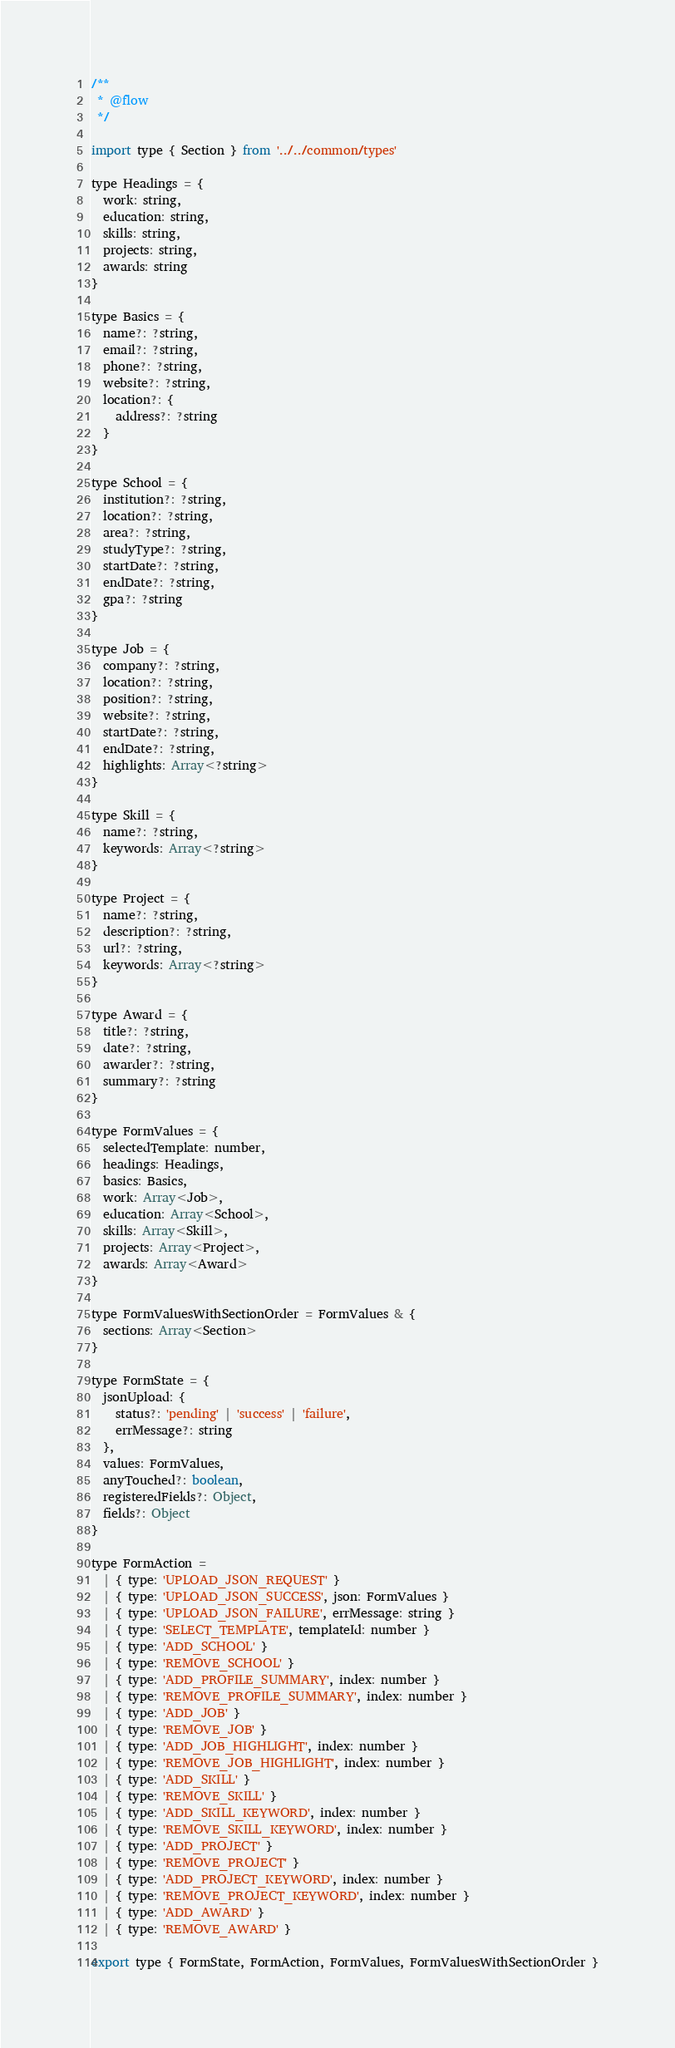<code> <loc_0><loc_0><loc_500><loc_500><_JavaScript_>/**
 * @flow
 */

import type { Section } from '../../common/types'

type Headings = {
  work: string,
  education: string,
  skills: string,
  projects: string,
  awards: string
}

type Basics = {
  name?: ?string,
  email?: ?string,
  phone?: ?string,
  website?: ?string,
  location?: {
    address?: ?string
  }
}

type School = {
  institution?: ?string,
  location?: ?string,
  area?: ?string,
  studyType?: ?string,
  startDate?: ?string,
  endDate?: ?string,
  gpa?: ?string
}

type Job = {
  company?: ?string,
  location?: ?string,
  position?: ?string,
  website?: ?string,
  startDate?: ?string,
  endDate?: ?string,
  highlights: Array<?string>
}

type Skill = {
  name?: ?string,
  keywords: Array<?string>
}

type Project = {
  name?: ?string,
  description?: ?string,
  url?: ?string,
  keywords: Array<?string>
}

type Award = {
  title?: ?string,
  date?: ?string,
  awarder?: ?string,
  summary?: ?string
}

type FormValues = {
  selectedTemplate: number,
  headings: Headings,
  basics: Basics,
  work: Array<Job>,
  education: Array<School>,
  skills: Array<Skill>,
  projects: Array<Project>,
  awards: Array<Award>
}

type FormValuesWithSectionOrder = FormValues & {
  sections: Array<Section>
}

type FormState = {
  jsonUpload: {
    status?: 'pending' | 'success' | 'failure',
    errMessage?: string
  },
  values: FormValues,
  anyTouched?: boolean,
  registeredFields?: Object,
  fields?: Object
}

type FormAction =
  | { type: 'UPLOAD_JSON_REQUEST' }
  | { type: 'UPLOAD_JSON_SUCCESS', json: FormValues }
  | { type: 'UPLOAD_JSON_FAILURE', errMessage: string }
  | { type: 'SELECT_TEMPLATE', templateId: number }
  | { type: 'ADD_SCHOOL' }
  | { type: 'REMOVE_SCHOOL' }
  | { type: 'ADD_PROFILE_SUMMARY', index: number }
  | { type: 'REMOVE_PROFILE_SUMMARY', index: number }
  | { type: 'ADD_JOB' }
  | { type: 'REMOVE_JOB' }
  | { type: 'ADD_JOB_HIGHLIGHT', index: number }
  | { type: 'REMOVE_JOB_HIGHLIGHT', index: number }
  | { type: 'ADD_SKILL' }
  | { type: 'REMOVE_SKILL' }
  | { type: 'ADD_SKILL_KEYWORD', index: number }
  | { type: 'REMOVE_SKILL_KEYWORD', index: number }
  | { type: 'ADD_PROJECT' }
  | { type: 'REMOVE_PROJECT' }
  | { type: 'ADD_PROJECT_KEYWORD', index: number }
  | { type: 'REMOVE_PROJECT_KEYWORD', index: number }
  | { type: 'ADD_AWARD' }
  | { type: 'REMOVE_AWARD' }

export type { FormState, FormAction, FormValues, FormValuesWithSectionOrder }
</code> 